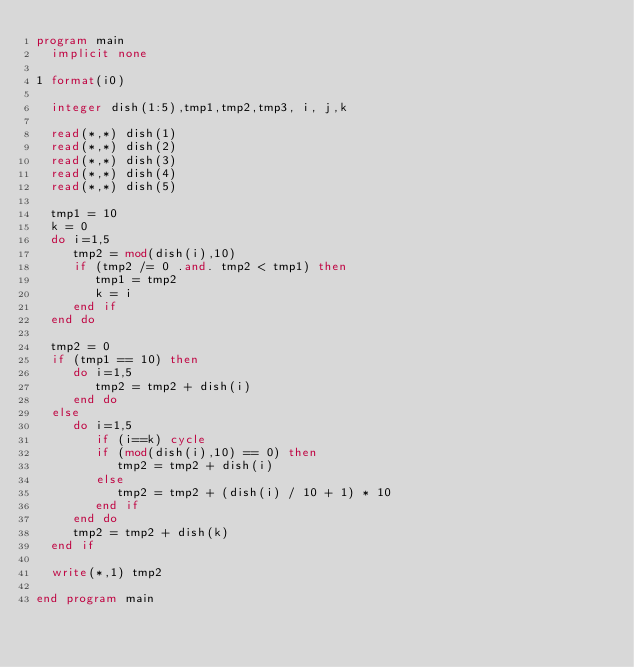Convert code to text. <code><loc_0><loc_0><loc_500><loc_500><_FORTRAN_>program main
  implicit none

1 format(i0)
  
  integer dish(1:5),tmp1,tmp2,tmp3, i, j,k
  
  read(*,*) dish(1)
  read(*,*) dish(2)
  read(*,*) dish(3)
  read(*,*) dish(4)
  read(*,*) dish(5)
  
  tmp1 = 10
  k = 0
  do i=1,5
     tmp2 = mod(dish(i),10)
     if (tmp2 /= 0 .and. tmp2 < tmp1) then
        tmp1 = tmp2
        k = i
     end if
  end do
  
  tmp2 = 0
  if (tmp1 == 10) then
     do i=1,5
        tmp2 = tmp2 + dish(i)        
     end do
  else
     do i=1,5
        if (i==k) cycle
        if (mod(dish(i),10) == 0) then
           tmp2 = tmp2 + dish(i)
        else
           tmp2 = tmp2 + (dish(i) / 10 + 1) * 10 
        end if
     end do
     tmp2 = tmp2 + dish(k)
  end if
  
  write(*,1) tmp2
  
end program main
  
  </code> 